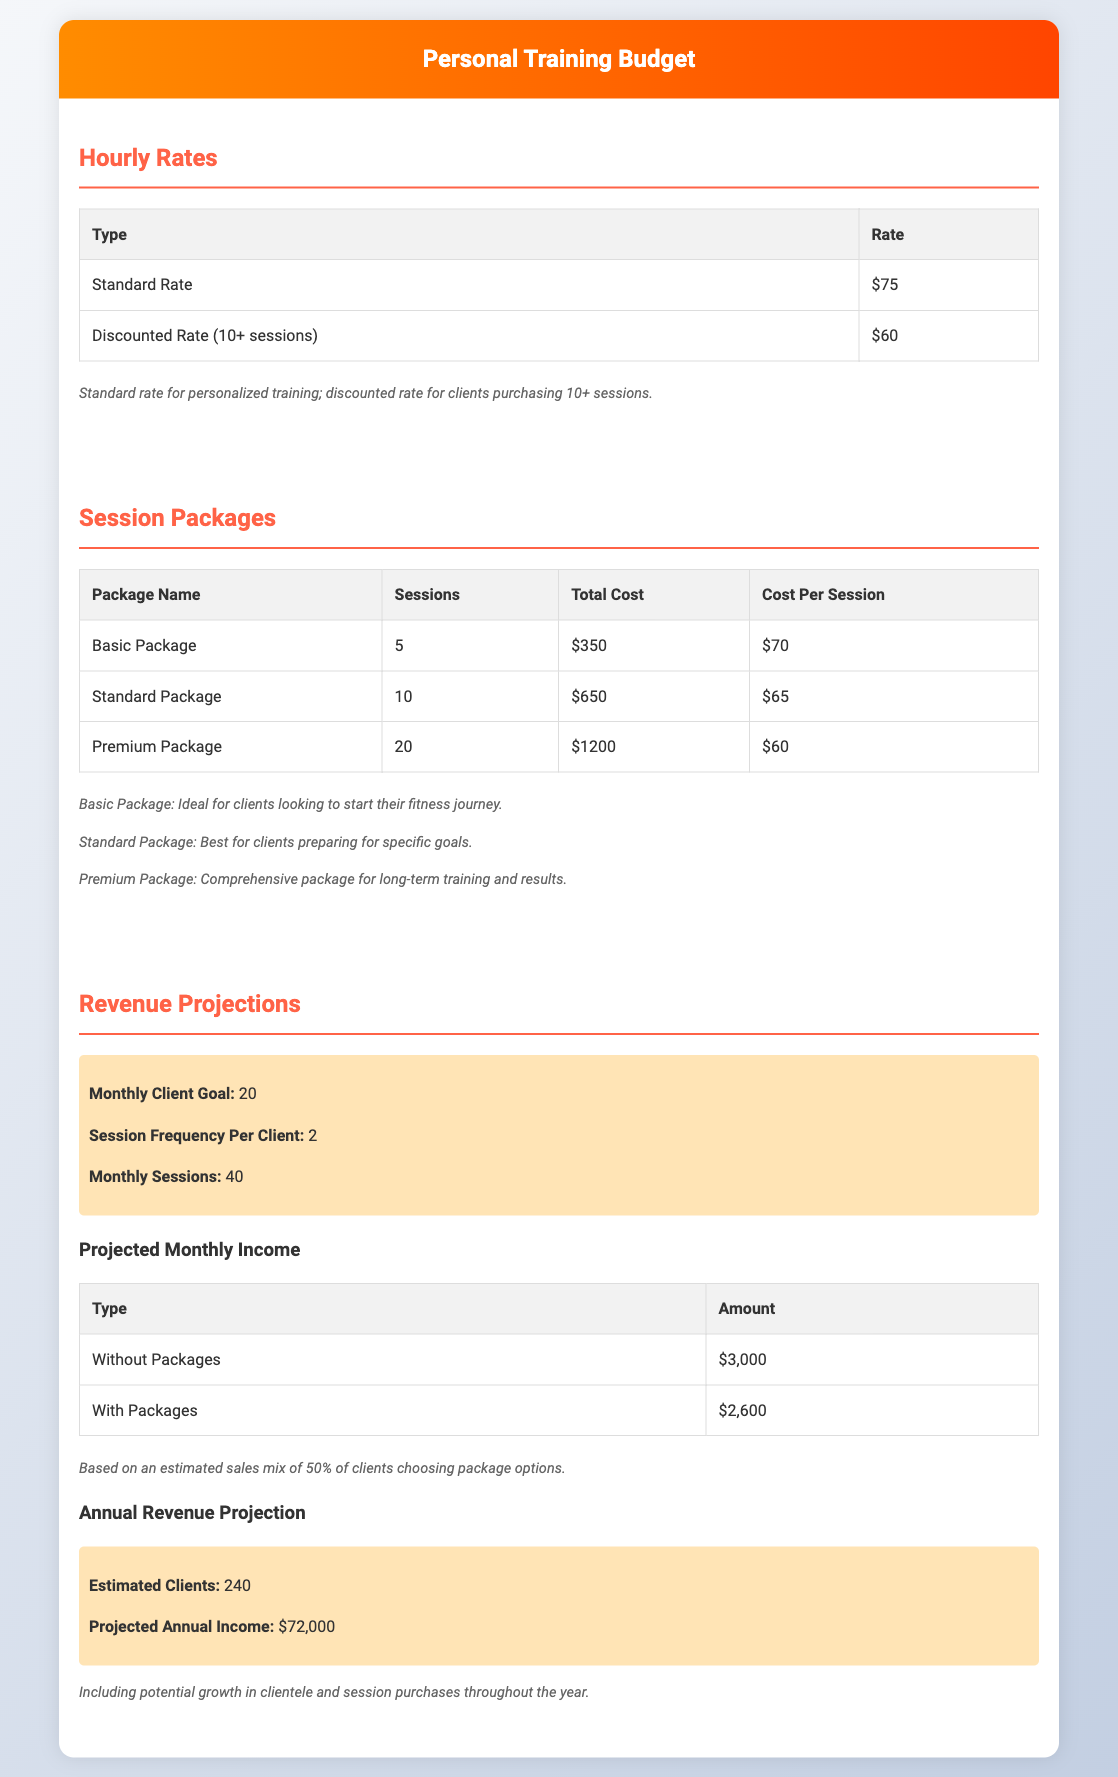What is the standard hourly rate for personal training? The document states that the standard rate is $75 per session.
Answer: $75 What is the cost for the Premium Package? The Premium Package costs a total of $1200 for 20 sessions.
Answer: $1200 How many sessions are included in the Standard Package? The Standard Package includes 10 sessions.
Answer: 10 What is the projected monthly income without packages? The projected monthly income without packages is $3000.
Answer: $3000 What percentage of clients is expected to choose package options? The document estimates that 50% of clients will choose package options.
Answer: 50% What is the monthly client goal? The monthly client goal is set at 20 clients.
Answer: 20 What is the total number of sessions projected per month? The document states there will be 40 sessions per month.
Answer: 40 What is the projected annual income? The projected annual income is $72,000 based on estimated clients and sessions.
Answer: $72,000 